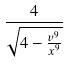<formula> <loc_0><loc_0><loc_500><loc_500>\frac { 4 } { \sqrt { 4 - \frac { v ^ { 9 } } { x ^ { 9 } } } }</formula> 